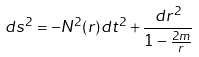Convert formula to latex. <formula><loc_0><loc_0><loc_500><loc_500>d s ^ { 2 } = - N ^ { 2 } ( r ) d t ^ { 2 } + \frac { d r ^ { 2 } } { 1 - \frac { 2 m } { r } }</formula> 